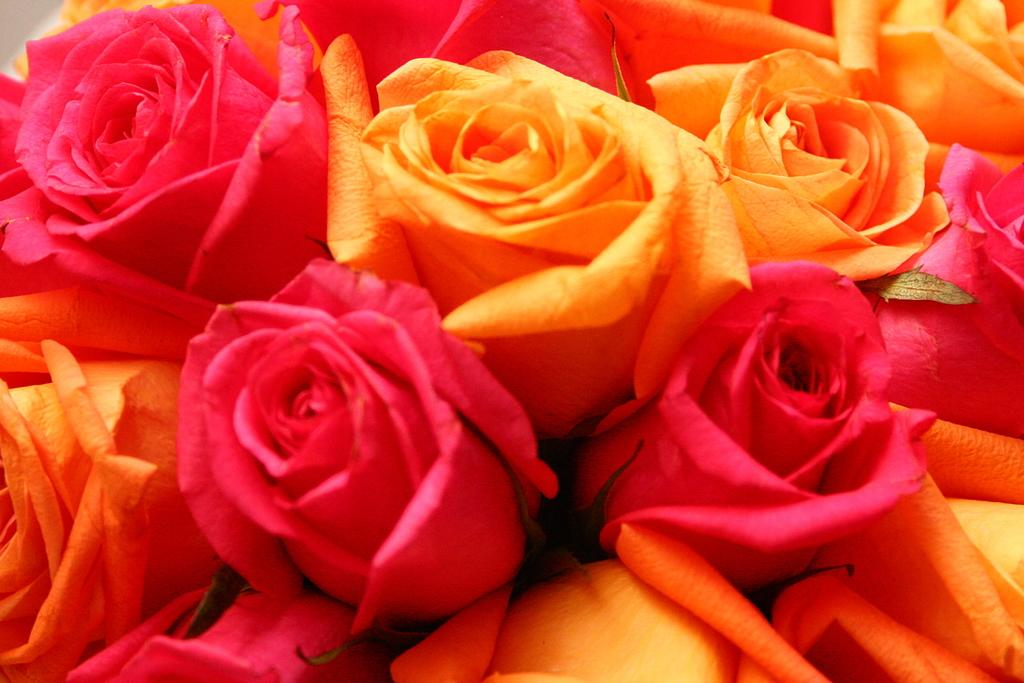What type of flowers are present in the image? There are roses in the image. Can you describe the appearance of the roses? The roses have petals and a stem, and they may be in various colors. Are there any other objects or elements in the image besides the roses? The provided facts do not mention any other objects or elements in the image. What type of connection can be seen between the roses and the horse in the image? There is no horse present in the image, so there is no connection between the roses and a horse. 